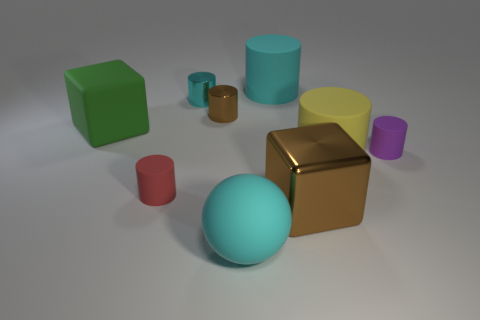What number of big objects are the same color as the large matte sphere?
Provide a short and direct response. 1. Are there any other things that have the same shape as the large metal object?
Give a very brief answer. Yes. How many cubes are tiny brown metal things or large matte things?
Offer a very short reply. 1. The rubber cylinder behind the large green object is what color?
Provide a short and direct response. Cyan. What shape is the red thing that is the same size as the purple matte object?
Provide a succinct answer. Cylinder. There is a big ball; what number of brown metallic cylinders are to the right of it?
Your answer should be very brief. 0. How many objects are big blue rubber things or shiny cylinders?
Your answer should be compact. 2. There is a metal object that is both in front of the tiny cyan thing and to the left of the large rubber sphere; what is its shape?
Provide a succinct answer. Cylinder. How many small metallic cylinders are there?
Make the answer very short. 2. The big block that is the same material as the ball is what color?
Keep it short and to the point. Green. 